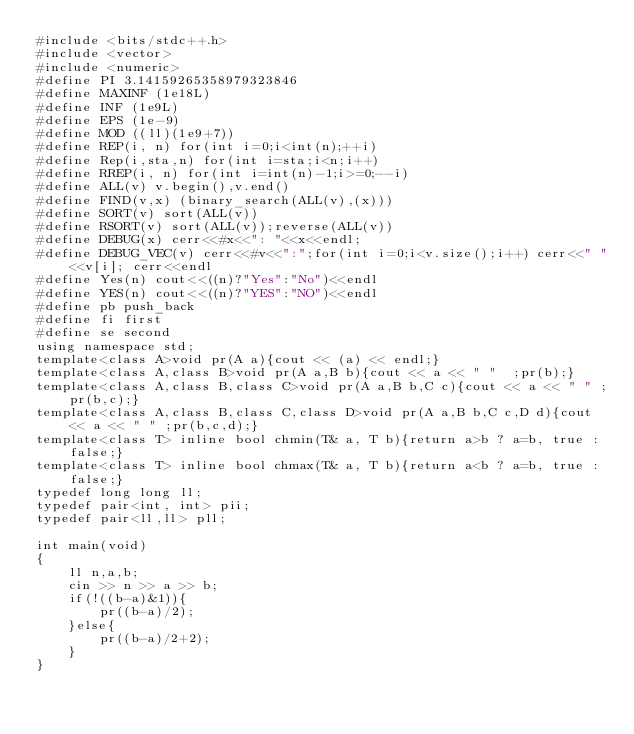<code> <loc_0><loc_0><loc_500><loc_500><_C++_>#include <bits/stdc++.h>
#include <vector>
#include <numeric>
#define PI 3.14159265358979323846
#define MAXINF (1e18L)
#define INF (1e9L)
#define EPS (1e-9)
#define MOD ((ll)(1e9+7))
#define REP(i, n) for(int i=0;i<int(n);++i)
#define Rep(i,sta,n) for(int i=sta;i<n;i++)
#define RREP(i, n) for(int i=int(n)-1;i>=0;--i)
#define ALL(v) v.begin(),v.end()
#define FIND(v,x) (binary_search(ALL(v),(x)))
#define SORT(v) sort(ALL(v))
#define RSORT(v) sort(ALL(v));reverse(ALL(v))
#define DEBUG(x) cerr<<#x<<": "<<x<<endl;
#define DEBUG_VEC(v) cerr<<#v<<":";for(int i=0;i<v.size();i++) cerr<<" "<<v[i]; cerr<<endl
#define Yes(n) cout<<((n)?"Yes":"No")<<endl
#define YES(n) cout<<((n)?"YES":"NO")<<endl
#define pb push_back
#define fi first
#define se second
using namespace std;
template<class A>void pr(A a){cout << (a) << endl;}
template<class A,class B>void pr(A a,B b){cout << a << " "  ;pr(b);}
template<class A,class B,class C>void pr(A a,B b,C c){cout << a << " " ;pr(b,c);}
template<class A,class B,class C,class D>void pr(A a,B b,C c,D d){cout << a << " " ;pr(b,c,d);}
template<class T> inline bool chmin(T& a, T b){return a>b ? a=b, true : false;}
template<class T> inline bool chmax(T& a, T b){return a<b ? a=b, true : false;}
typedef long long ll;
typedef pair<int, int> pii;
typedef pair<ll,ll> pll;

int main(void)
{
    ll n,a,b;
    cin >> n >> a >> b;
    if(!((b-a)&1)){
        pr((b-a)/2);
    }else{
        pr((b-a)/2+2);
    }
}</code> 